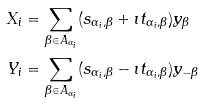Convert formula to latex. <formula><loc_0><loc_0><loc_500><loc_500>X _ { i } & = \sum _ { \beta \in A _ { \alpha _ { i } } } ( s _ { \alpha _ { i } , \beta } + \imath t _ { \alpha _ { i } , \beta } ) y _ { \beta } \\ Y _ { i } & = \sum _ { \beta \in A _ { \alpha _ { i } } } ( s _ { \alpha _ { i } , \beta } - \imath t _ { \alpha _ { i } , \beta } ) y _ { - \beta } \\</formula> 